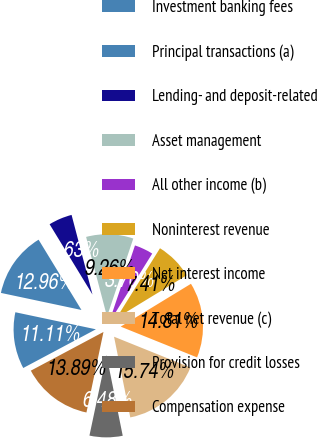Convert chart to OTSL. <chart><loc_0><loc_0><loc_500><loc_500><pie_chart><fcel>Investment banking fees<fcel>Principal transactions (a)<fcel>Lending- and deposit-related<fcel>Asset management<fcel>All other income (b)<fcel>Noninterest revenue<fcel>Net interest income<fcel>Total net revenue (c)<fcel>Provision for credit losses<fcel>Compensation expense<nl><fcel>11.11%<fcel>12.96%<fcel>4.63%<fcel>9.26%<fcel>3.7%<fcel>7.41%<fcel>14.81%<fcel>15.74%<fcel>6.48%<fcel>13.89%<nl></chart> 